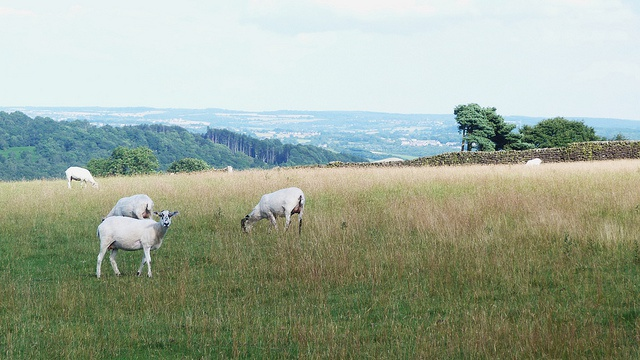Describe the objects in this image and their specific colors. I can see sheep in white, lightgray, darkgray, gray, and black tones, sheep in white, lightgray, darkgray, and gray tones, sheep in white, lightgray, darkgray, and gray tones, sheep in white, beige, darkgray, and gray tones, and sheep in white, lightgray, darkgray, gray, and tan tones in this image. 